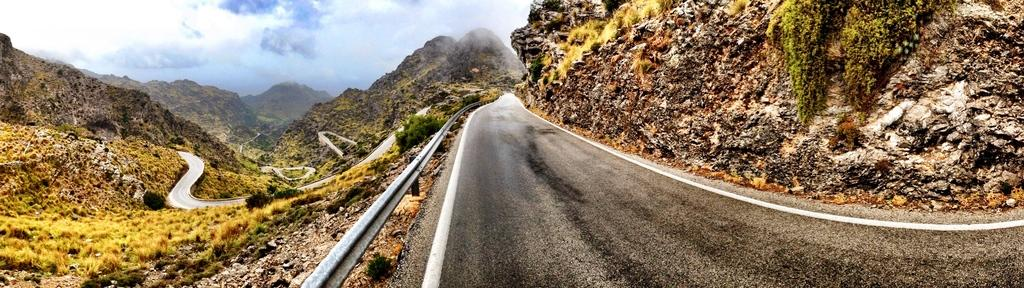What type of terrain can be seen in the image? There are roads and grass visible in the image. What type of natural landform is visible in the image? There are mountains visible in the image. What is present at the top of the image? Clouds are present at the top of the image. How many cows are grazing on the sugar in the image? There are no cows or sugar present in the image. What type of beef is being served in the image? There is no beef present in the image. 